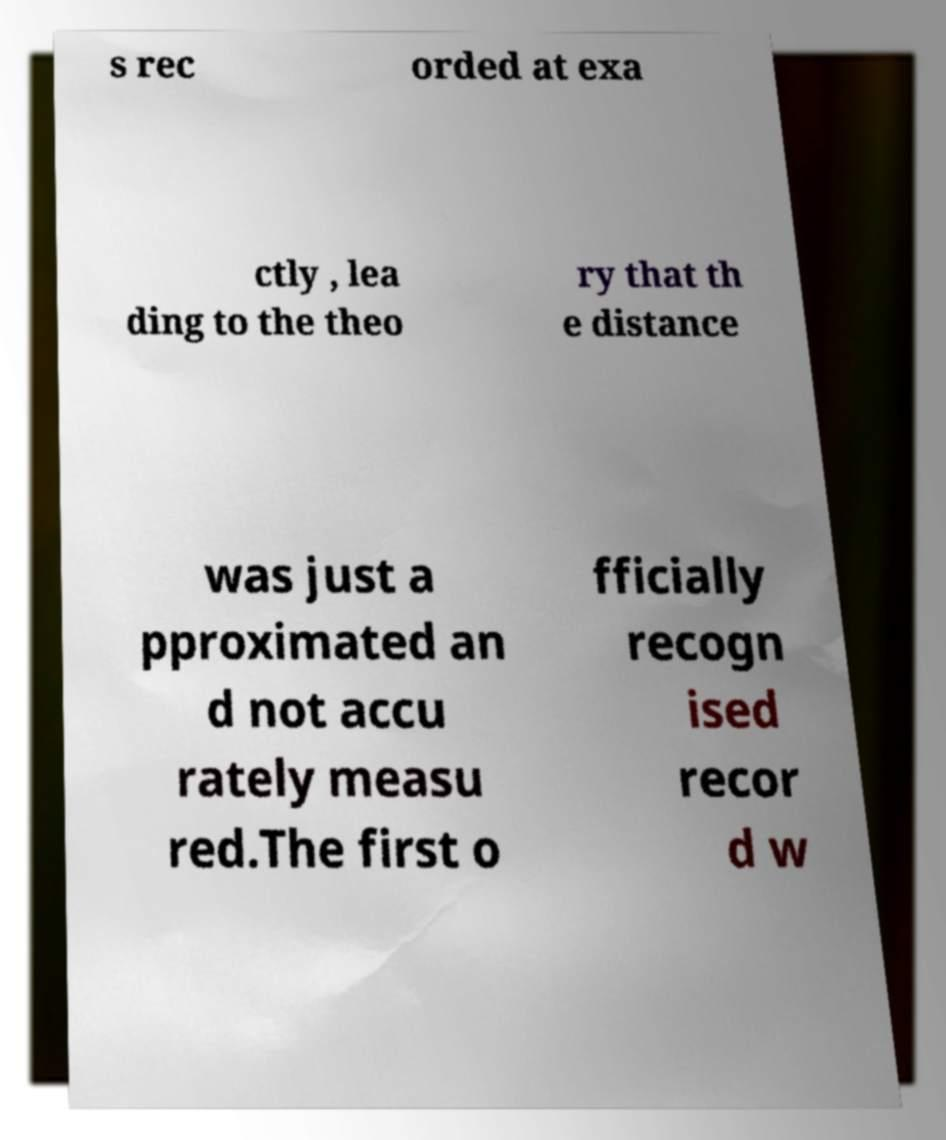Can you read and provide the text displayed in the image?This photo seems to have some interesting text. Can you extract and type it out for me? s rec orded at exa ctly , lea ding to the theo ry that th e distance was just a pproximated an d not accu rately measu red.The first o fficially recogn ised recor d w 